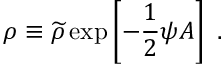Convert formula to latex. <formula><loc_0><loc_0><loc_500><loc_500>\rho \equiv \widetilde { \rho } \exp \left [ - { \frac { 1 } { 2 } } \psi A \right ] .</formula> 